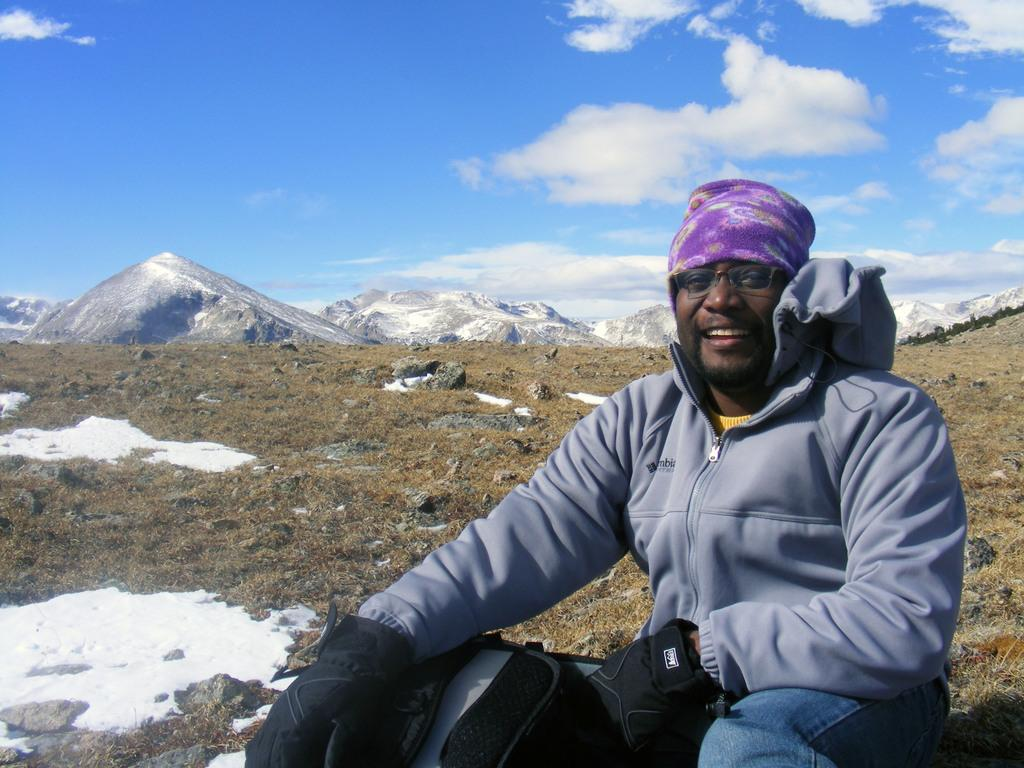What is the position of the man in the image? There is a man sitting in the front of the image. What is the man's facial expression? The man is smiling. What type of vegetation can be seen in the background of the image? There is dry grass in the background of the image. What geographical features are visible in the background of the image? There are mountains visible in the background of the image. How would you describe the weather based on the sky in the image? The sky is cloudy in the image. Where is the sister of the man in the image? There is no mention of a sister in the image, so we cannot determine her location. What type of cream is being used by the toad in the image? There is no toad or cream present in the image. 